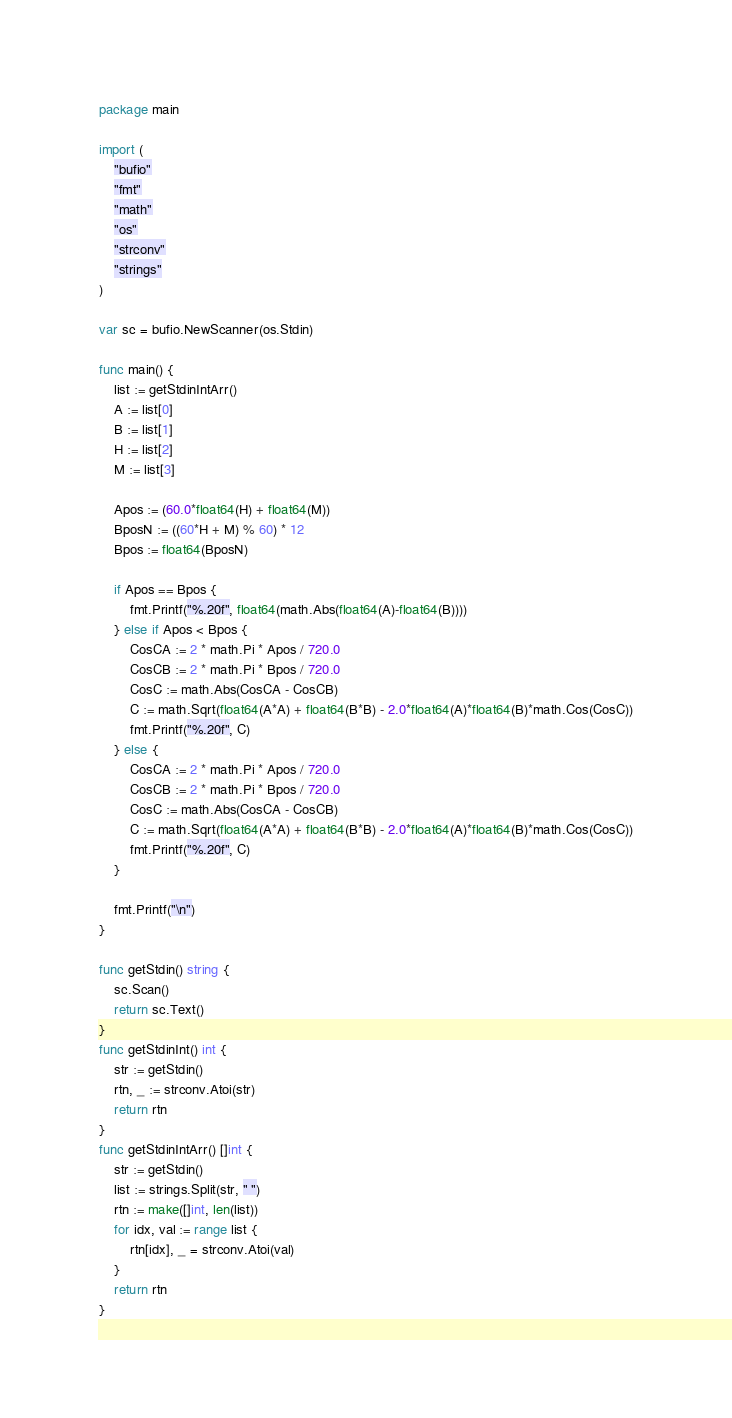<code> <loc_0><loc_0><loc_500><loc_500><_Go_>package main

import (
	"bufio"
	"fmt"
	"math"
	"os"
	"strconv"
	"strings"
)

var sc = bufio.NewScanner(os.Stdin)

func main() {
	list := getStdinIntArr()
	A := list[0]
	B := list[1]
	H := list[2]
	M := list[3]

	Apos := (60.0*float64(H) + float64(M))
	BposN := ((60*H + M) % 60) * 12
	Bpos := float64(BposN)

	if Apos == Bpos {
		fmt.Printf("%.20f", float64(math.Abs(float64(A)-float64(B))))
	} else if Apos < Bpos {
		CosCA := 2 * math.Pi * Apos / 720.0
		CosCB := 2 * math.Pi * Bpos / 720.0
		CosC := math.Abs(CosCA - CosCB)
		C := math.Sqrt(float64(A*A) + float64(B*B) - 2.0*float64(A)*float64(B)*math.Cos(CosC))
		fmt.Printf("%.20f", C)
	} else {
		CosCA := 2 * math.Pi * Apos / 720.0
		CosCB := 2 * math.Pi * Bpos / 720.0
		CosC := math.Abs(CosCA - CosCB)
		C := math.Sqrt(float64(A*A) + float64(B*B) - 2.0*float64(A)*float64(B)*math.Cos(CosC))
		fmt.Printf("%.20f", C)
	}

	fmt.Printf("\n")
}

func getStdin() string {
	sc.Scan()
	return sc.Text()
}
func getStdinInt() int {
	str := getStdin()
	rtn, _ := strconv.Atoi(str)
	return rtn
}
func getStdinIntArr() []int {
	str := getStdin()
	list := strings.Split(str, " ")
	rtn := make([]int, len(list))
	for idx, val := range list {
		rtn[idx], _ = strconv.Atoi(val)
	}
	return rtn
}
</code> 